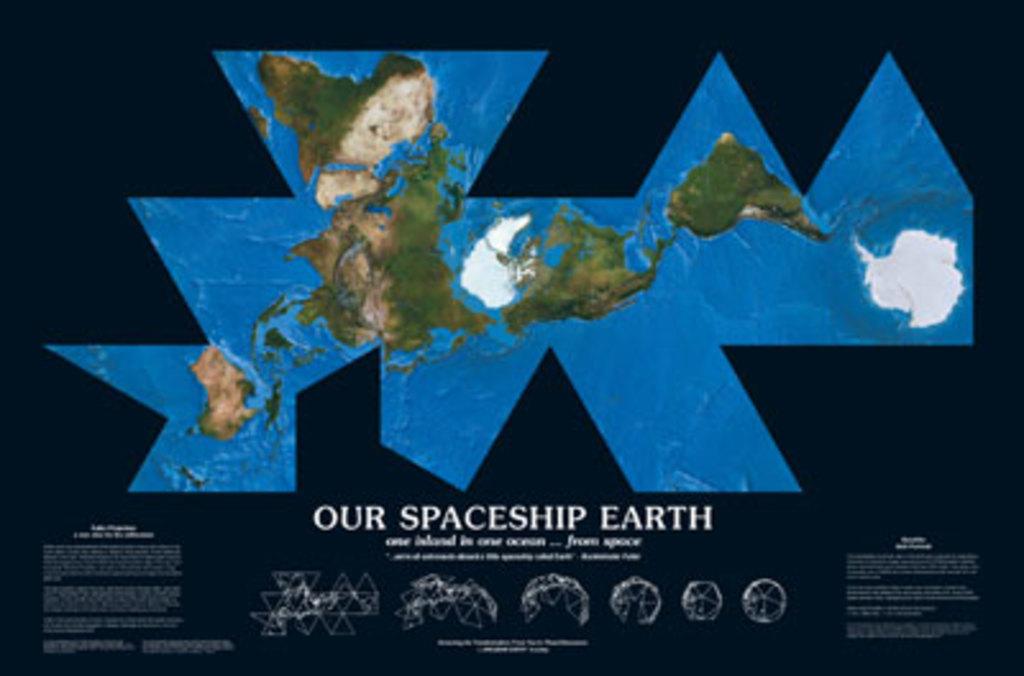What is the word after our?
Your answer should be very brief. Spaceship. What planet is displayed?
Make the answer very short. Earth. 